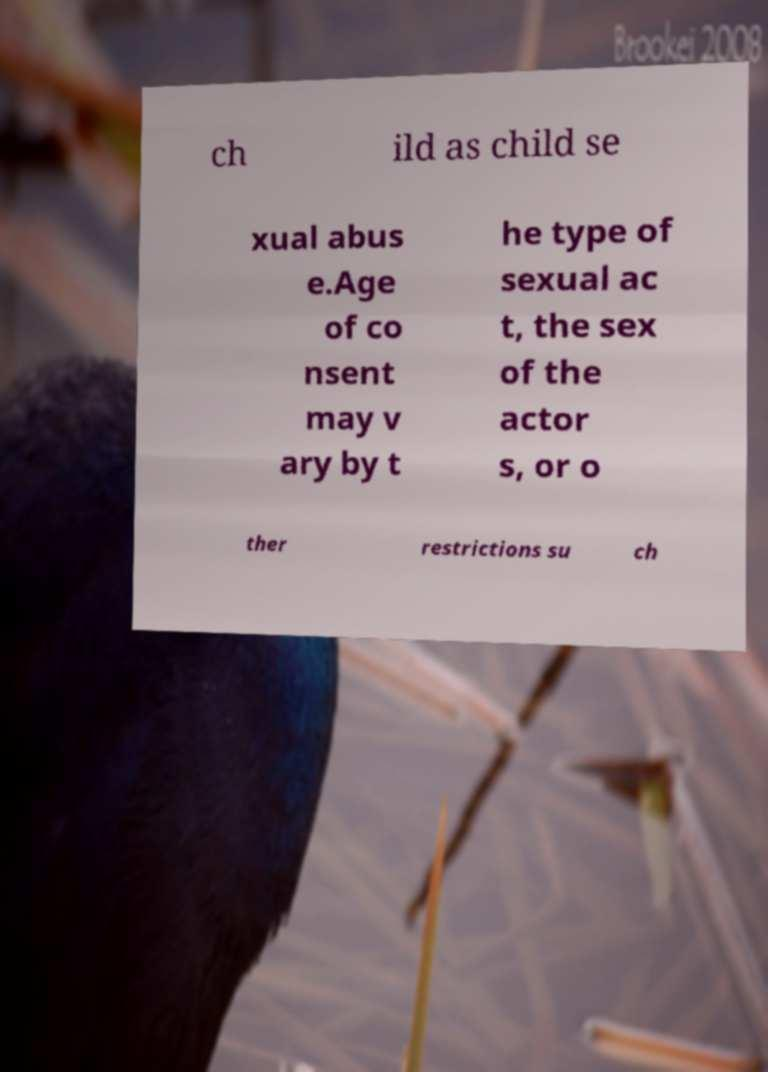Can you accurately transcribe the text from the provided image for me? ch ild as child se xual abus e.Age of co nsent may v ary by t he type of sexual ac t, the sex of the actor s, or o ther restrictions su ch 